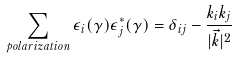<formula> <loc_0><loc_0><loc_500><loc_500>\sum _ { p o l a r i z a t i o n } \epsilon _ { i } ( \gamma ) \epsilon ^ { * } _ { j } ( \gamma ) = \delta _ { i j } - \frac { k _ { i } k _ { j } } { | \vec { k } | ^ { 2 } }</formula> 